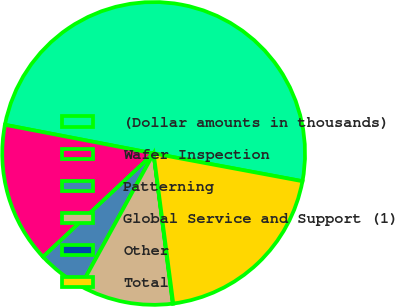Convert chart. <chart><loc_0><loc_0><loc_500><loc_500><pie_chart><fcel>(Dollar amounts in thousands)<fcel>Wafer Inspection<fcel>Patterning<fcel>Global Service and Support (1)<fcel>Other<fcel>Total<nl><fcel>49.9%<fcel>15.0%<fcel>5.03%<fcel>10.02%<fcel>0.05%<fcel>19.99%<nl></chart> 